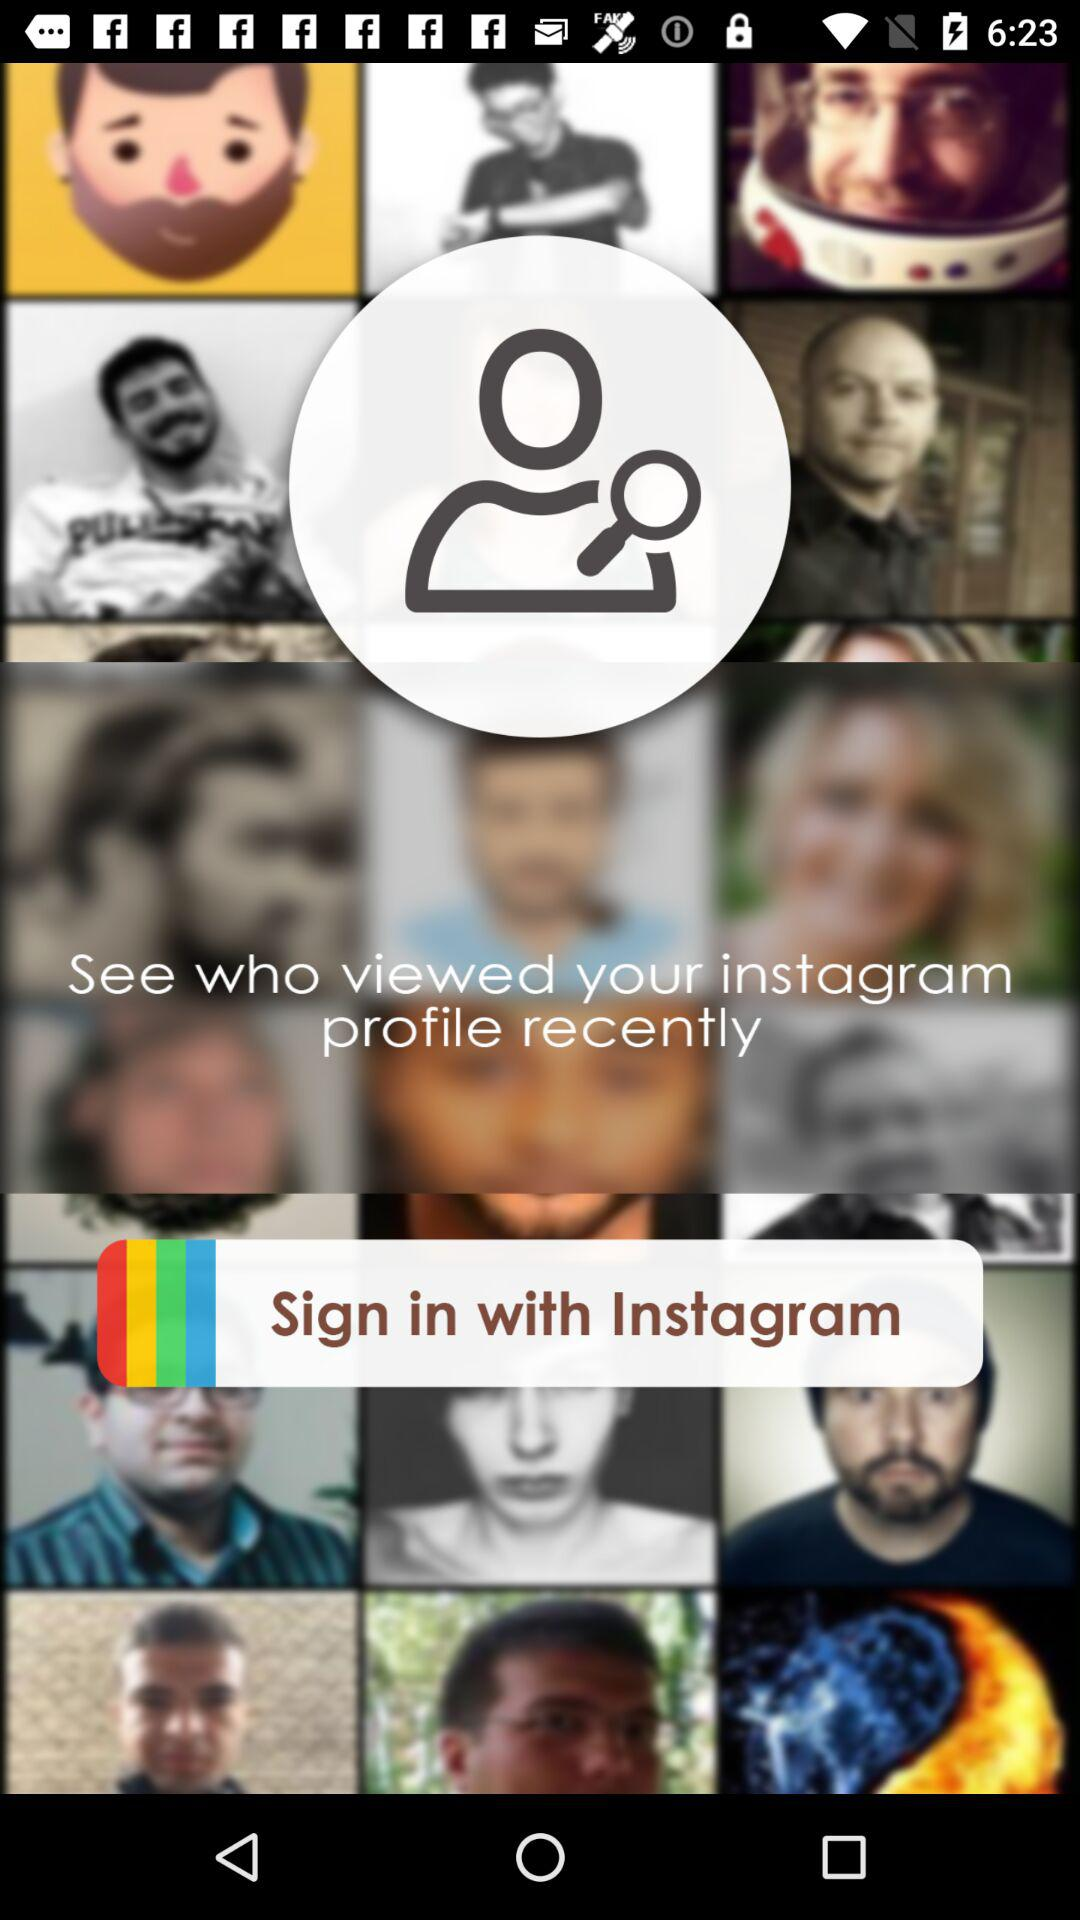Through what application can we sign in? You can sign in through "Instagram". 